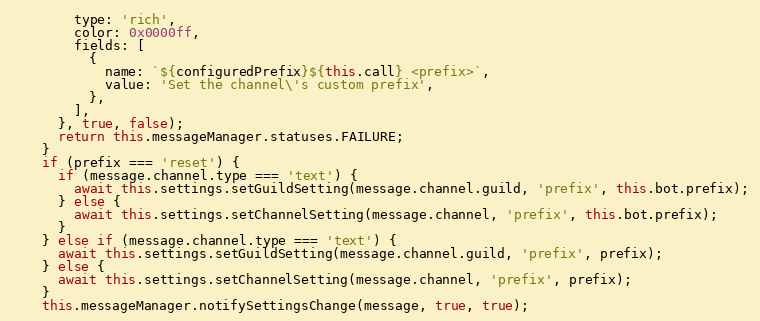<code> <loc_0><loc_0><loc_500><loc_500><_JavaScript_>        type: 'rich',
        color: 0x0000ff,
        fields: [
          {
            name: `${configuredPrefix}${this.call} <prefix>`,
            value: 'Set the channel\'s custom prefix',
          },
        ],
      }, true, false);
      return this.messageManager.statuses.FAILURE;
    }
    if (prefix === 'reset') {
      if (message.channel.type === 'text') {
        await this.settings.setGuildSetting(message.channel.guild, 'prefix', this.bot.prefix);
      } else {
        await this.settings.setChannelSetting(message.channel, 'prefix', this.bot.prefix);
      }
    } else if (message.channel.type === 'text') {
      await this.settings.setGuildSetting(message.channel.guild, 'prefix', prefix);
    } else {
      await this.settings.setChannelSetting(message.channel, 'prefix', prefix);
    }
    this.messageManager.notifySettingsChange(message, true, true);</code> 